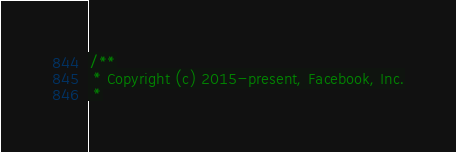<code> <loc_0><loc_0><loc_500><loc_500><_ObjectiveC_>/**
 * Copyright (c) 2015-present, Facebook, Inc.
 *</code> 